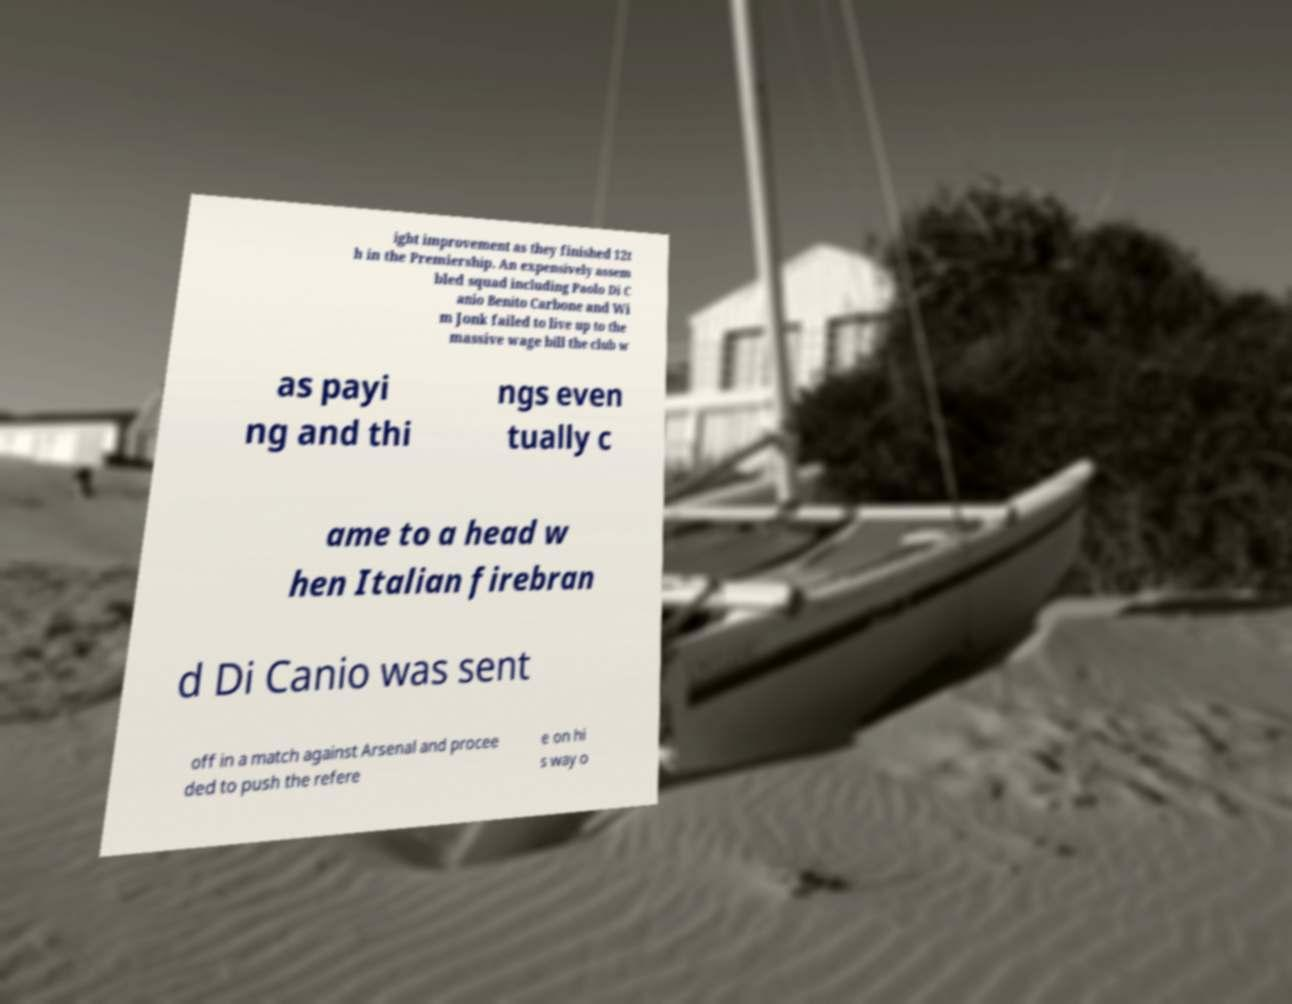I need the written content from this picture converted into text. Can you do that? ight improvement as they finished 12t h in the Premiership. An expensively assem bled squad including Paolo Di C anio Benito Carbone and Wi m Jonk failed to live up to the massive wage bill the club w as payi ng and thi ngs even tually c ame to a head w hen Italian firebran d Di Canio was sent off in a match against Arsenal and procee ded to push the refere e on hi s way o 